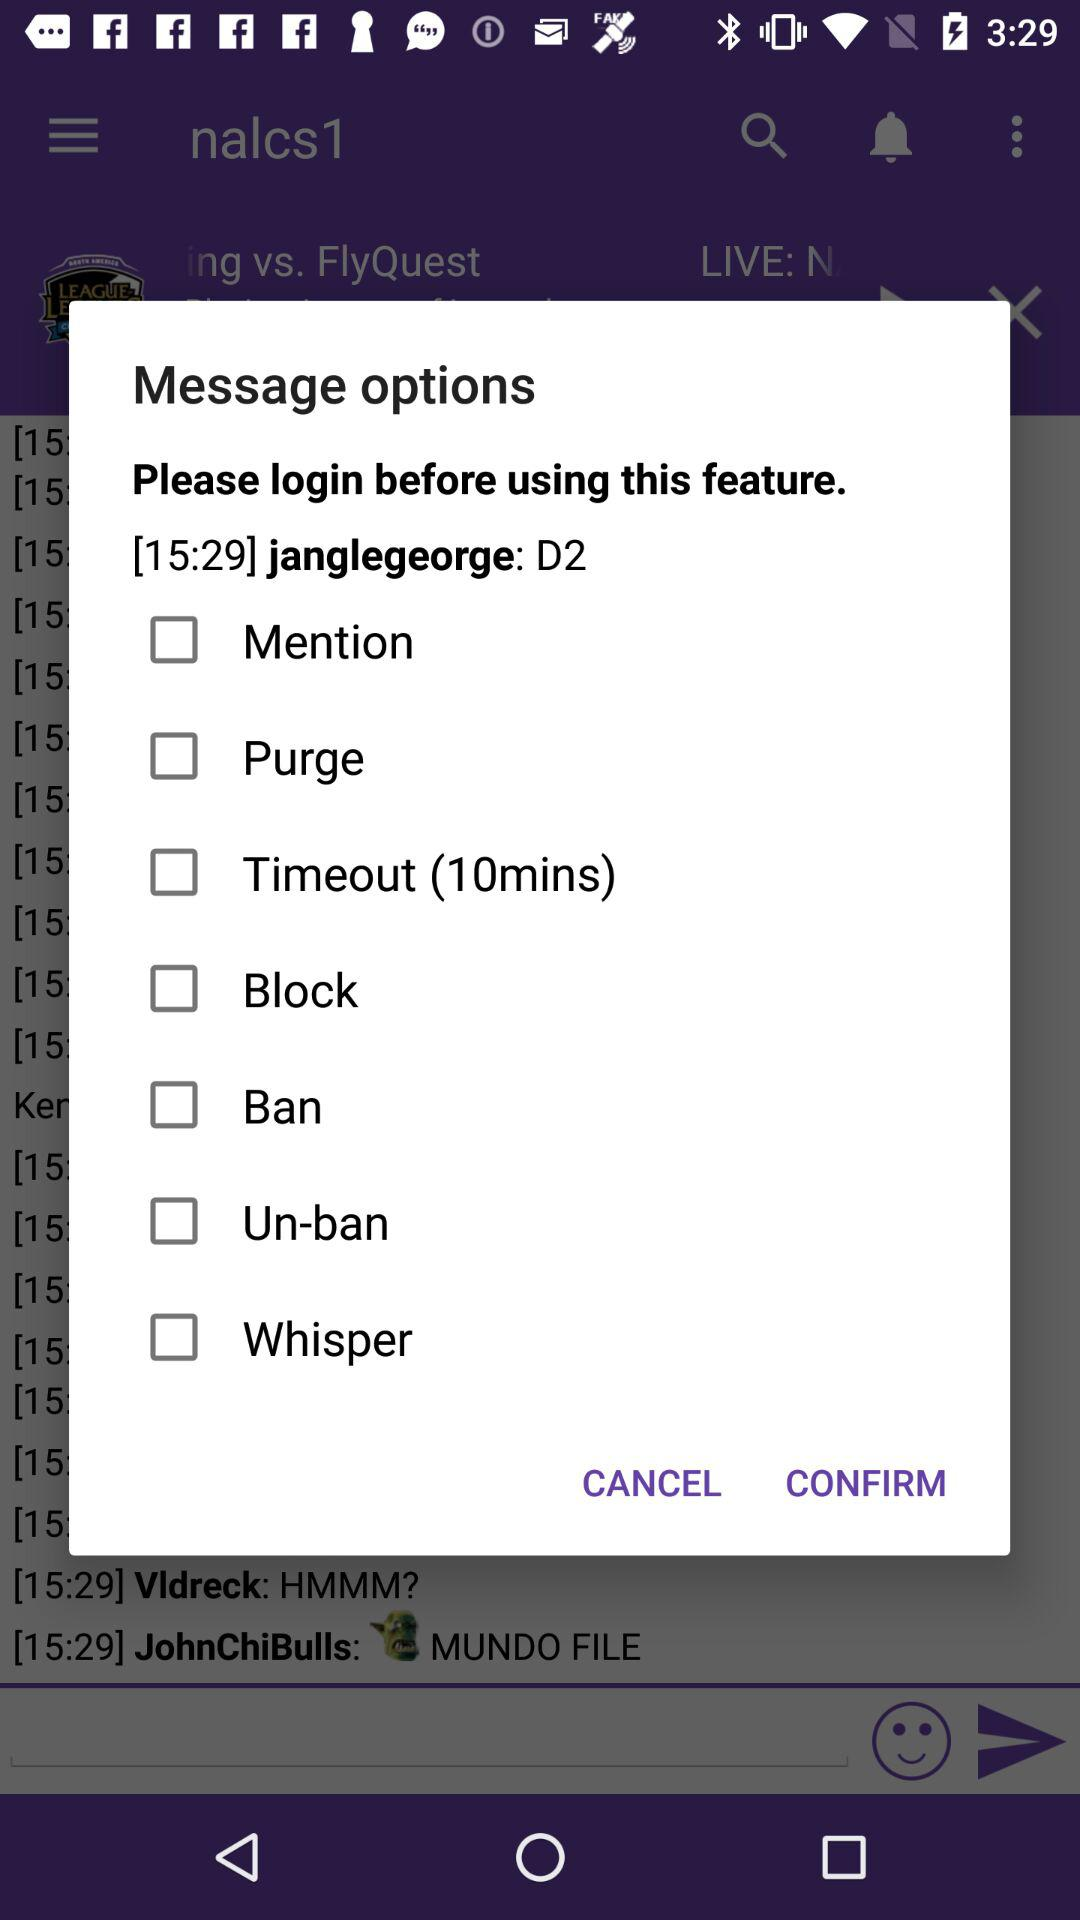What is the username? The usernames are "janglegeorge", "Vldreck" and "JohnChiBulls". 